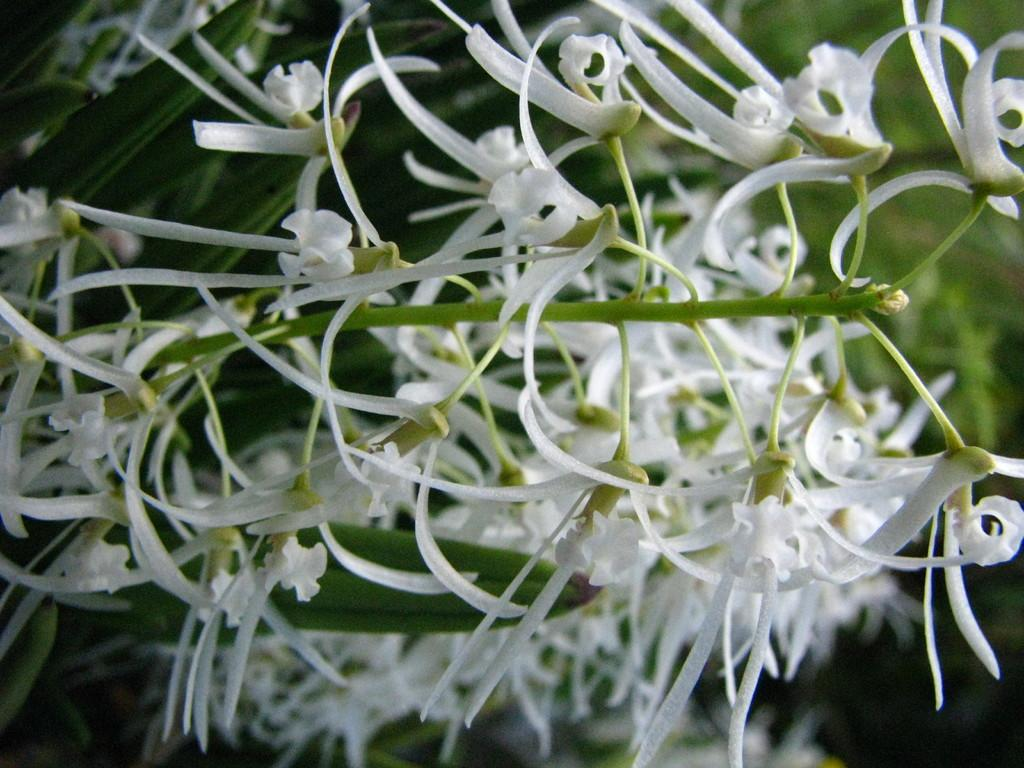What type of flowers can be seen in the image? There are white color flowers in the image. What color are the leaves associated with the flowers? There are green leaves in the image. How would you describe the overall clarity of the image? The image is slightly blurry in the background. What type of rake is being used to clean the scene in the image? There is no rake or scene present in the image; it features white color flowers and green leaves. In which room is the image taken? The image does not depict a room; it is an outdoor scene with flowers and leaves. 